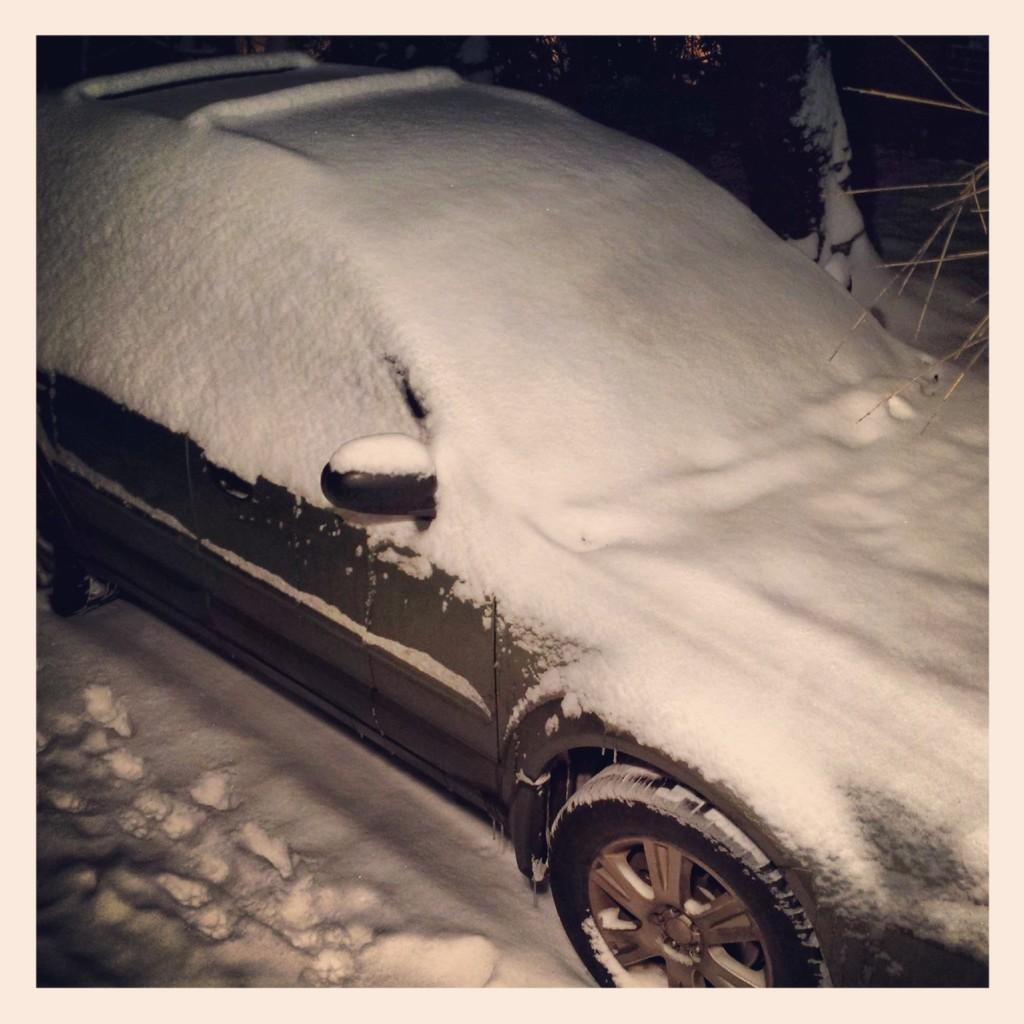What is the main subject of the image? There is a car in the image. How is the car affected by the weather in the image? The car is covered with snow. What can be seen in the background of the image? There is snow and a plant visible in the background. Can you tell me what the people are arguing about in the image? There are no people or arguments present in the image; it features a car covered in snow with a snowy background and a plant. What type of land is visible in the image? The image does not show any specific type of land; it primarily features a car, snow, and a plant. 